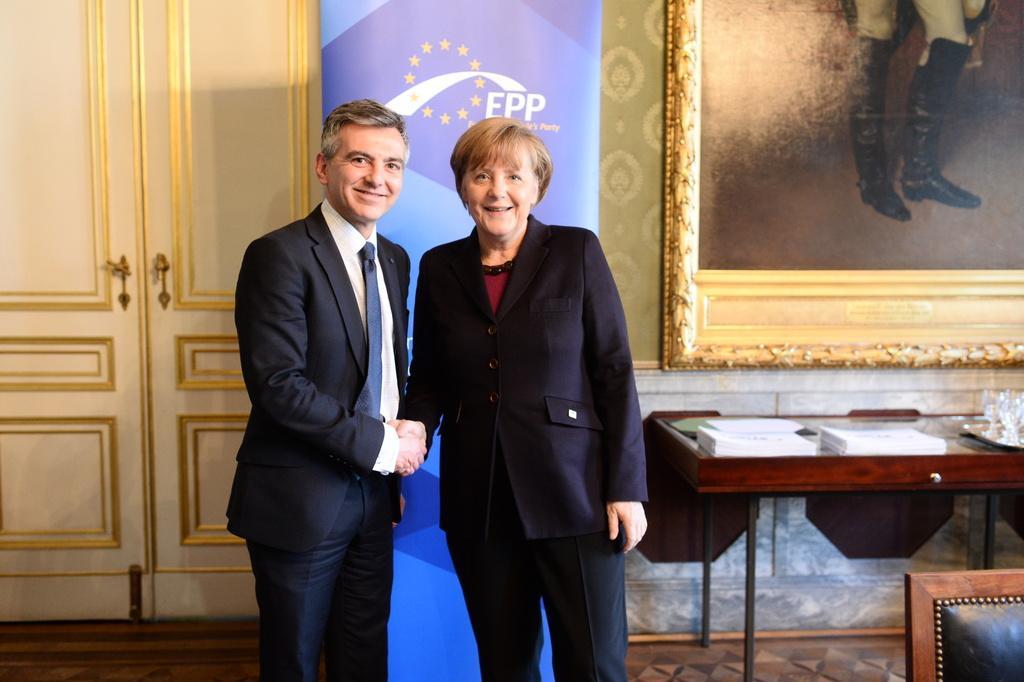How would you summarize this image in a sentence or two? In this image I can see a man and a woman are standing together and smiling. I can also see there is a table with some objects on it, a door and a photo on a wall. 